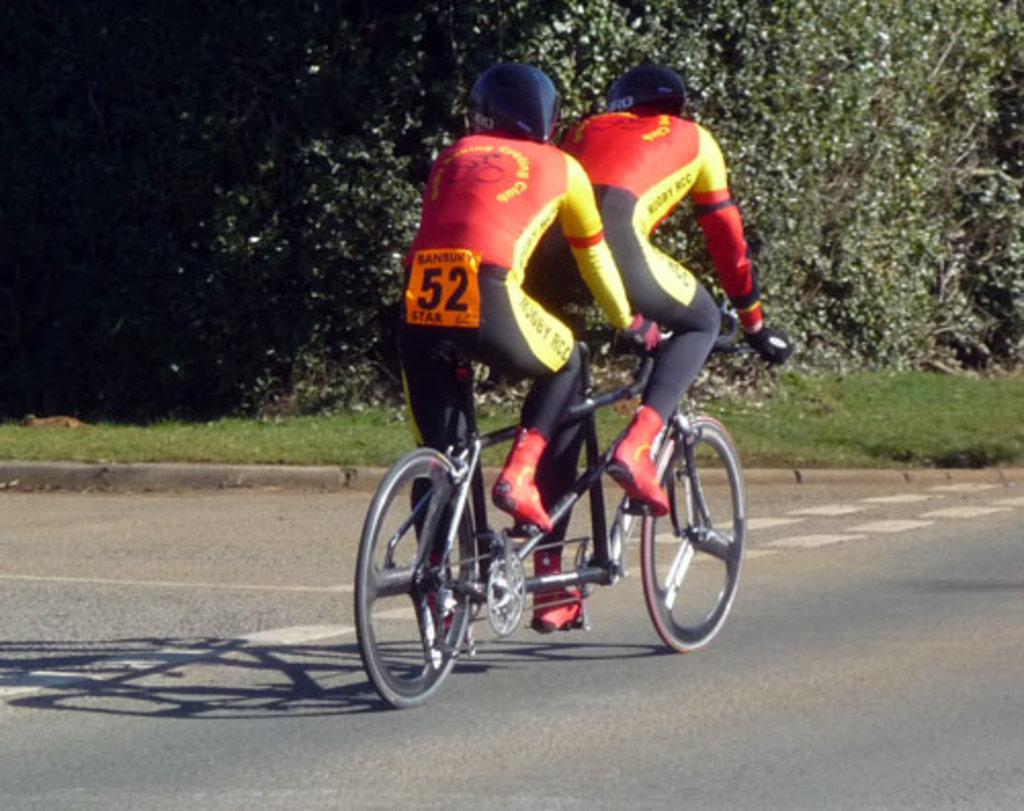Could you give a brief overview of what you see in this image? In this image there are two persons riding a tandem bicycle on the road surface, in the background of the image there are trees. 